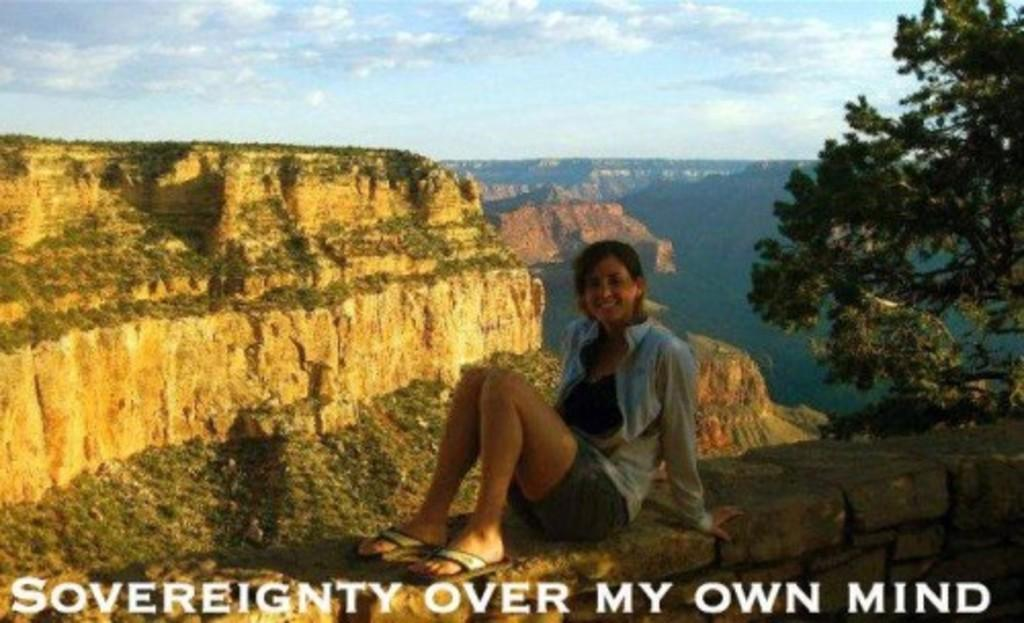Who is present in the image? There is a woman in the image. What is the woman doing in the image? The woman is sitting on a wall. What is the woman's facial expression in the image? The woman is smiling. What type of vegetation can be seen in the image? There is a tree visible in the image. What type of landscape is visible in the background of the image? There are mountains in the background of the image. What is visible in the sky in the image? The sky is visible in the background of the image, and clouds are present. What type of match is the woman holding in the image? There is no match present in the image. What type of skirt is the woman wearing in the image? The image does not show the woman's skirt, so it cannot be determined from the image. 